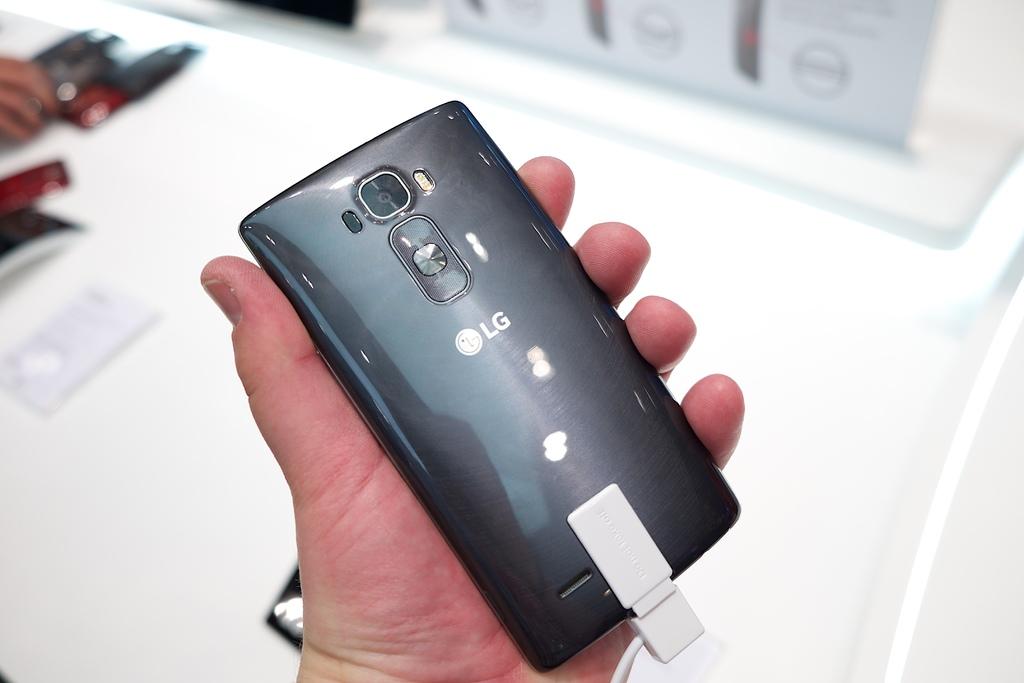What brand of phone is this?
Make the answer very short. Lg. What two letters are on the back of the phone?
Keep it short and to the point. Lg. 